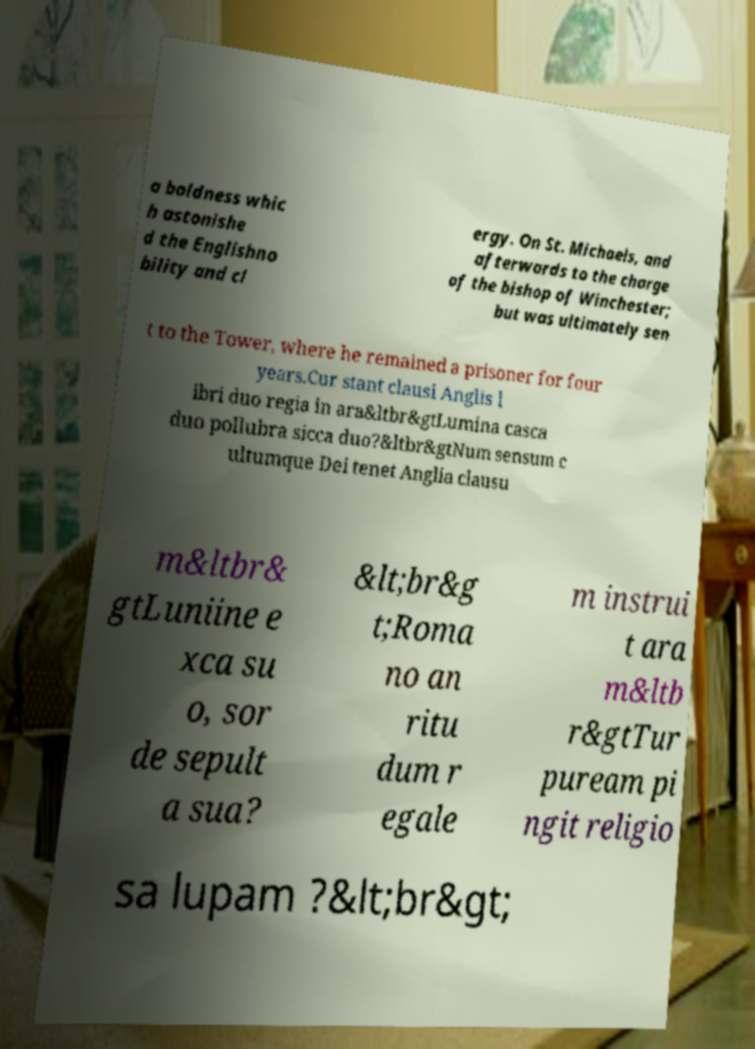Please identify and transcribe the text found in this image. a boldness whic h astonishe d the Englishno bility and cl ergy. On St. Michaels, and afterwards to the charge of the bishop of Winchester; but was ultimately sen t to the Tower, where he remained a prisoner for four years.Cur stant clausi Anglis l ibri duo regia in ara&ltbr&gtLumina casca duo pollubra sicca duo?&ltbr&gtNum sensum c ultumque Dei tenet Anglia clausu m&ltbr& gtLuniine e xca su o, sor de sepult a sua? &lt;br&g t;Roma no an ritu dum r egale m instrui t ara m&ltb r&gtTur puream pi ngit religio sa lupam ?&lt;br&gt; 